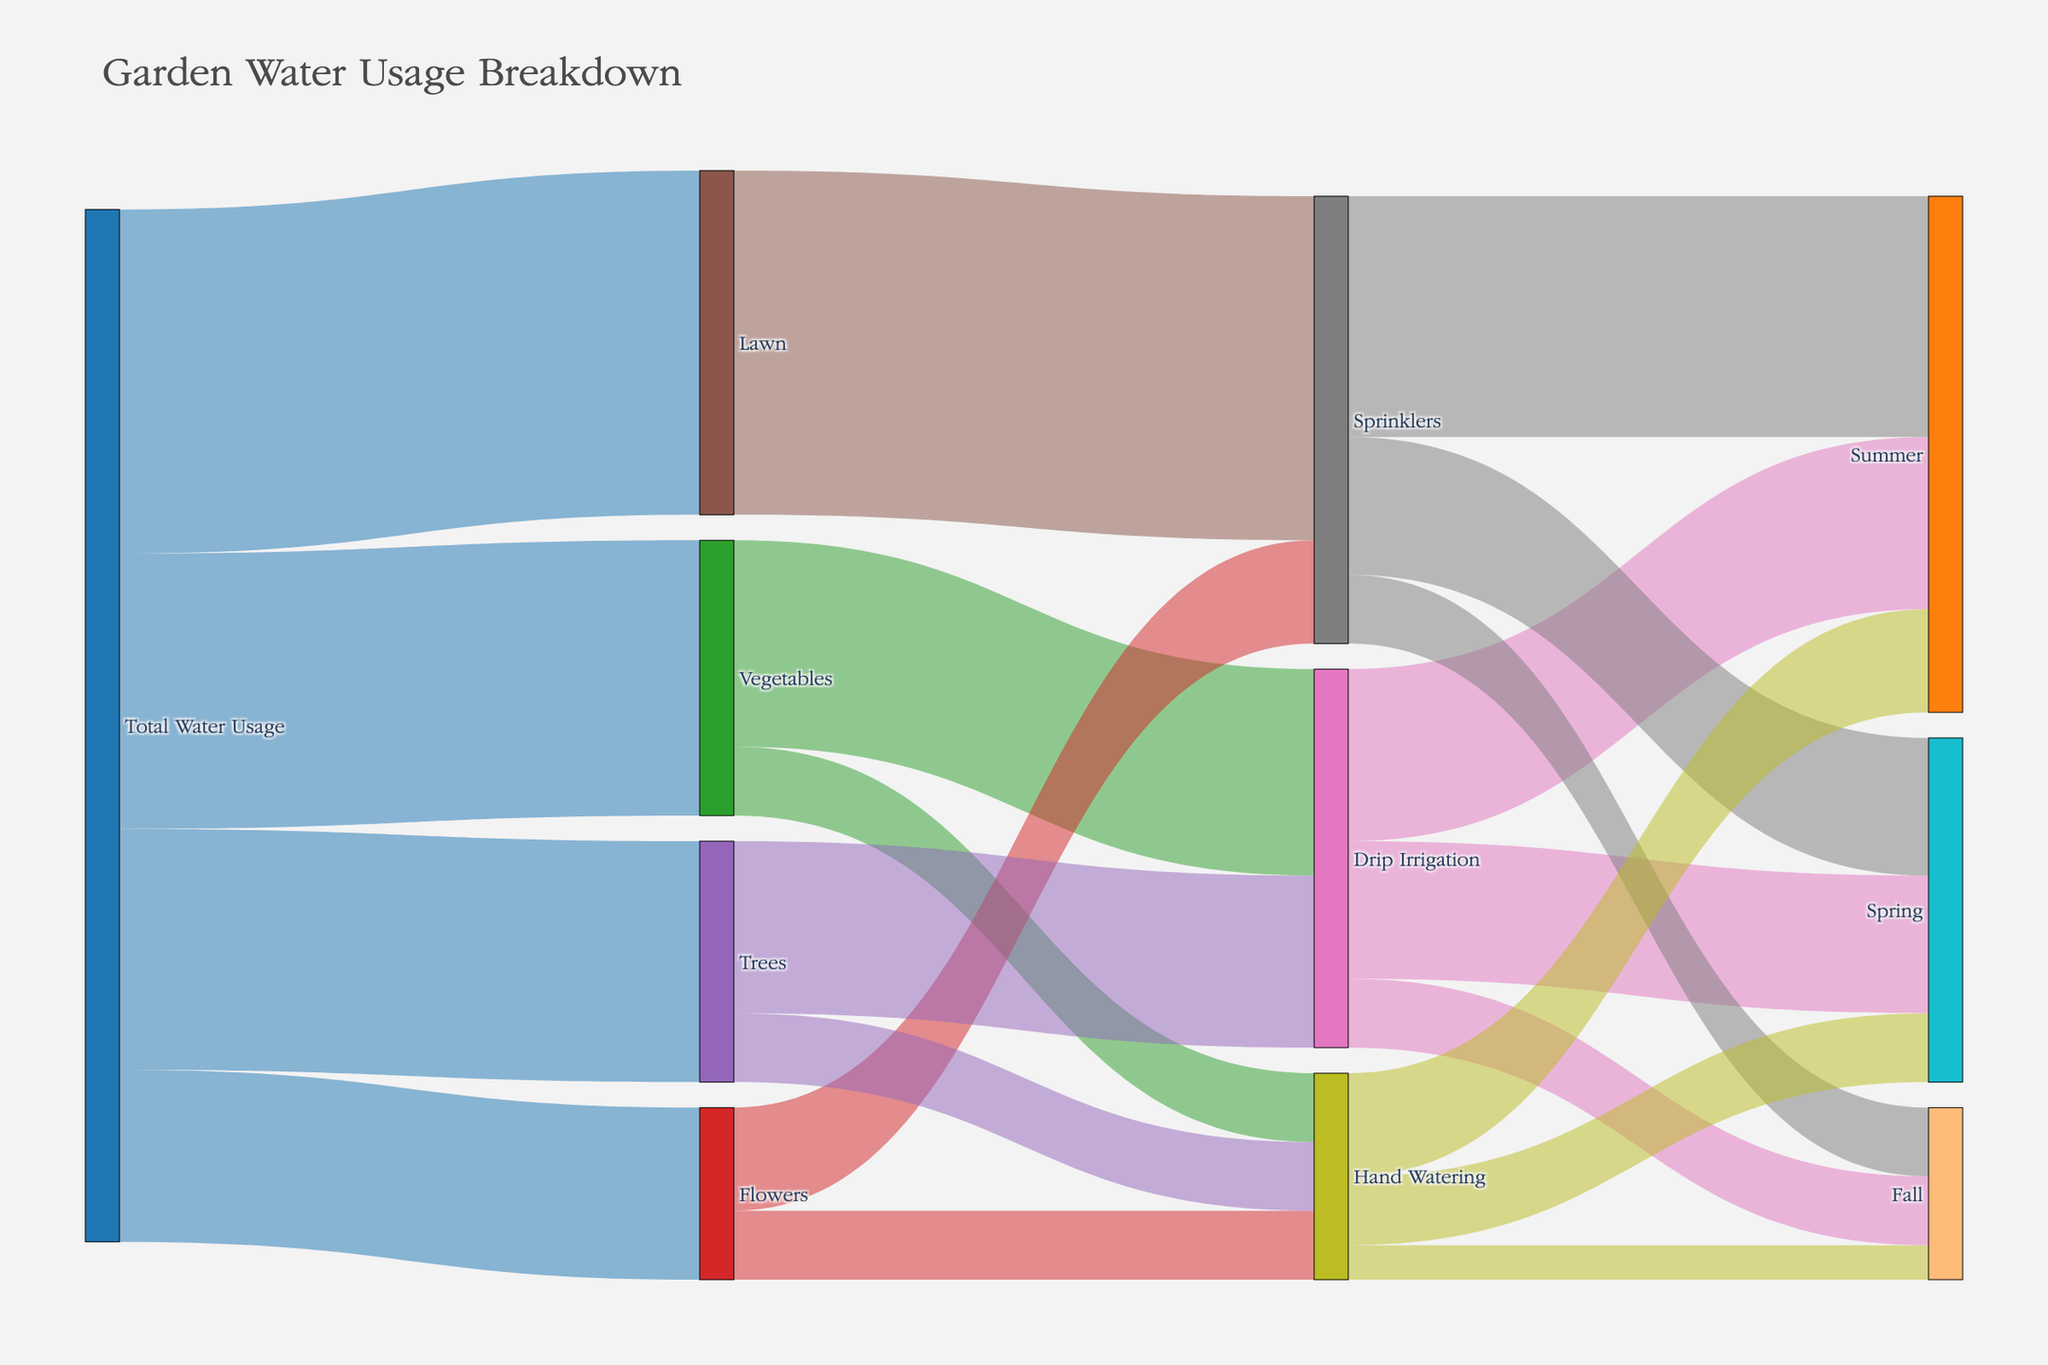What's the total amount of water used for trees? To find the total water used for trees, we sum the values flowing from "Total Water Usage" to "Trees." The value is provided as 3500.
Answer: 3500 What irrigation method uses the least amount of water for flowers? For flowers, the values are 1500 for sprinklers and 1000 for hand watering. The method with the least water usage is hand watering.
Answer: Hand Watering Which season has the highest water usage through drip irrigation? The values flowing from "Drip Irrigation" to seasons are 2000 (Spring), 2500 (Summer), and 1000 (Fall). The highest water usage is in summer.
Answer: Summer Compare the water usage for lawns and vegetables. Which one uses more water? The values flowing from "Total Water Usage" are 5000 for lawns and 4000 for vegetables. Lawns use more water.
Answer: Lawns What's the combined water usage for sprinkler irrigation in all seasons? Summing the values for sprinkler irrigation across all seasons: 2000 (Spring) + 3500 (Summer) + 1000 (Fall) = 6500.
Answer: 6500 How much water is used in total through hand watering? Summing the values for hand watering across all plants: 1000 (Vegetables) + 1000 (Flowers) + 1000 (Trees) = 3000. Then adding seasonal usage: 1000 (Spring) + 1500 (Summer) + 500 (Fall) = 3000 + 3000 = 6000.
Answer: 6000 What percentage of the total water usage is distributed to flowers? The total water usage to flowers is 2500. Given the total water usage is 15000 (sum of all initial values: 4000 + 2500 + 3500 + 5000), the percentage is (2500 / 15000) * 100 = 16.67%.
Answer: 16.67% How does the water usage in spring for drip irrigation compare to that in fall? The values for drip irrigation are 2000 in spring and 1000 in fall. Spring usage is double that of fall.
Answer: Spring usage is double Which plant type has the most diverse range of irrigation methods by visual assessment? Vegetables and trees have two methods each, but a quick visual assessment shows vegetables (drip and hand watering) may appear more prominent due to color distribution.
Answer: Vegetables 